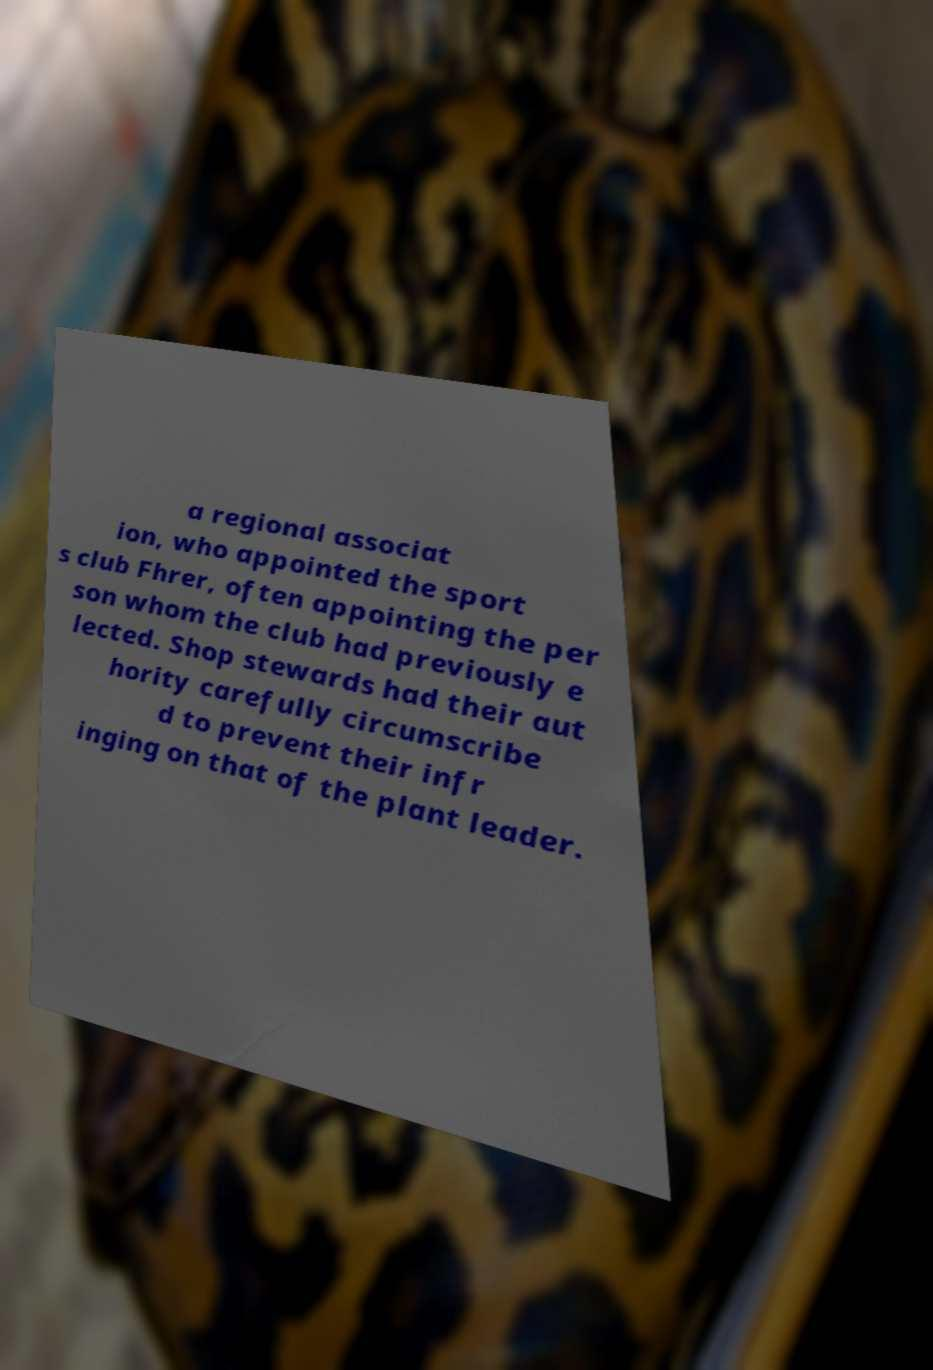Could you extract and type out the text from this image? a regional associat ion, who appointed the sport s club Fhrer, often appointing the per son whom the club had previously e lected. Shop stewards had their aut hority carefully circumscribe d to prevent their infr inging on that of the plant leader. 